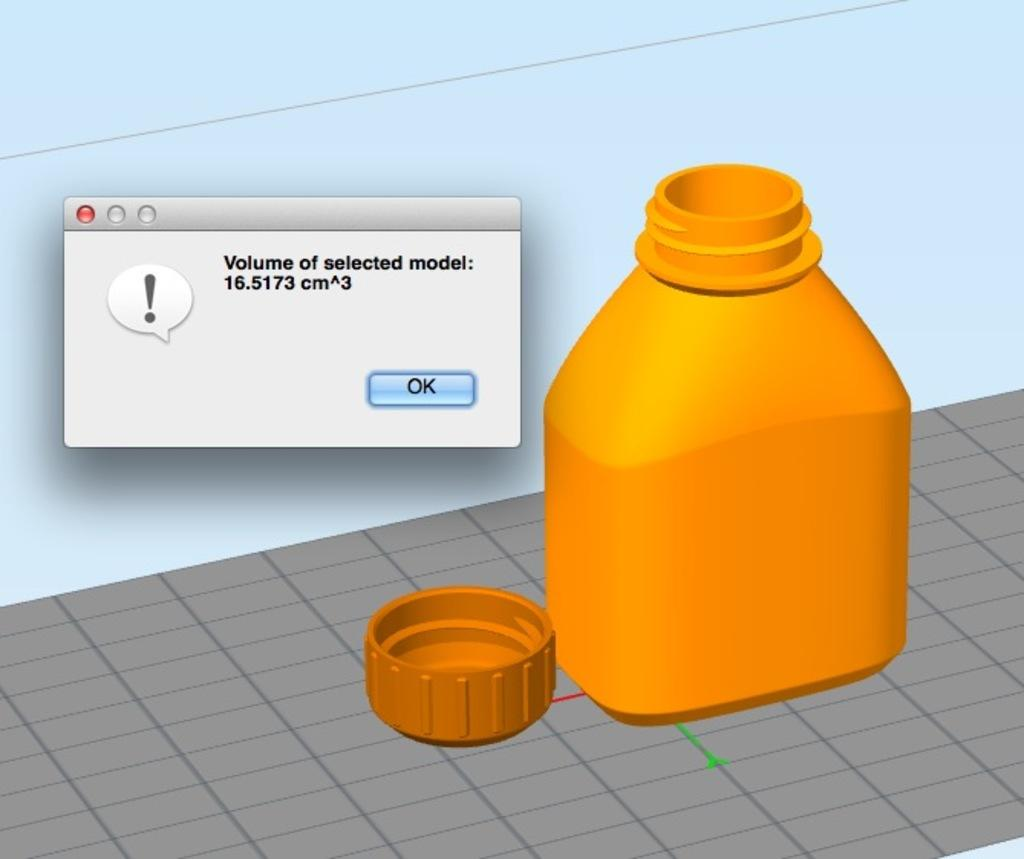<image>
Relay a brief, clear account of the picture shown. An open bottle is displayed on a computer screen as a simulation with a pop up to the left of it that reads the volume of the selected model. 